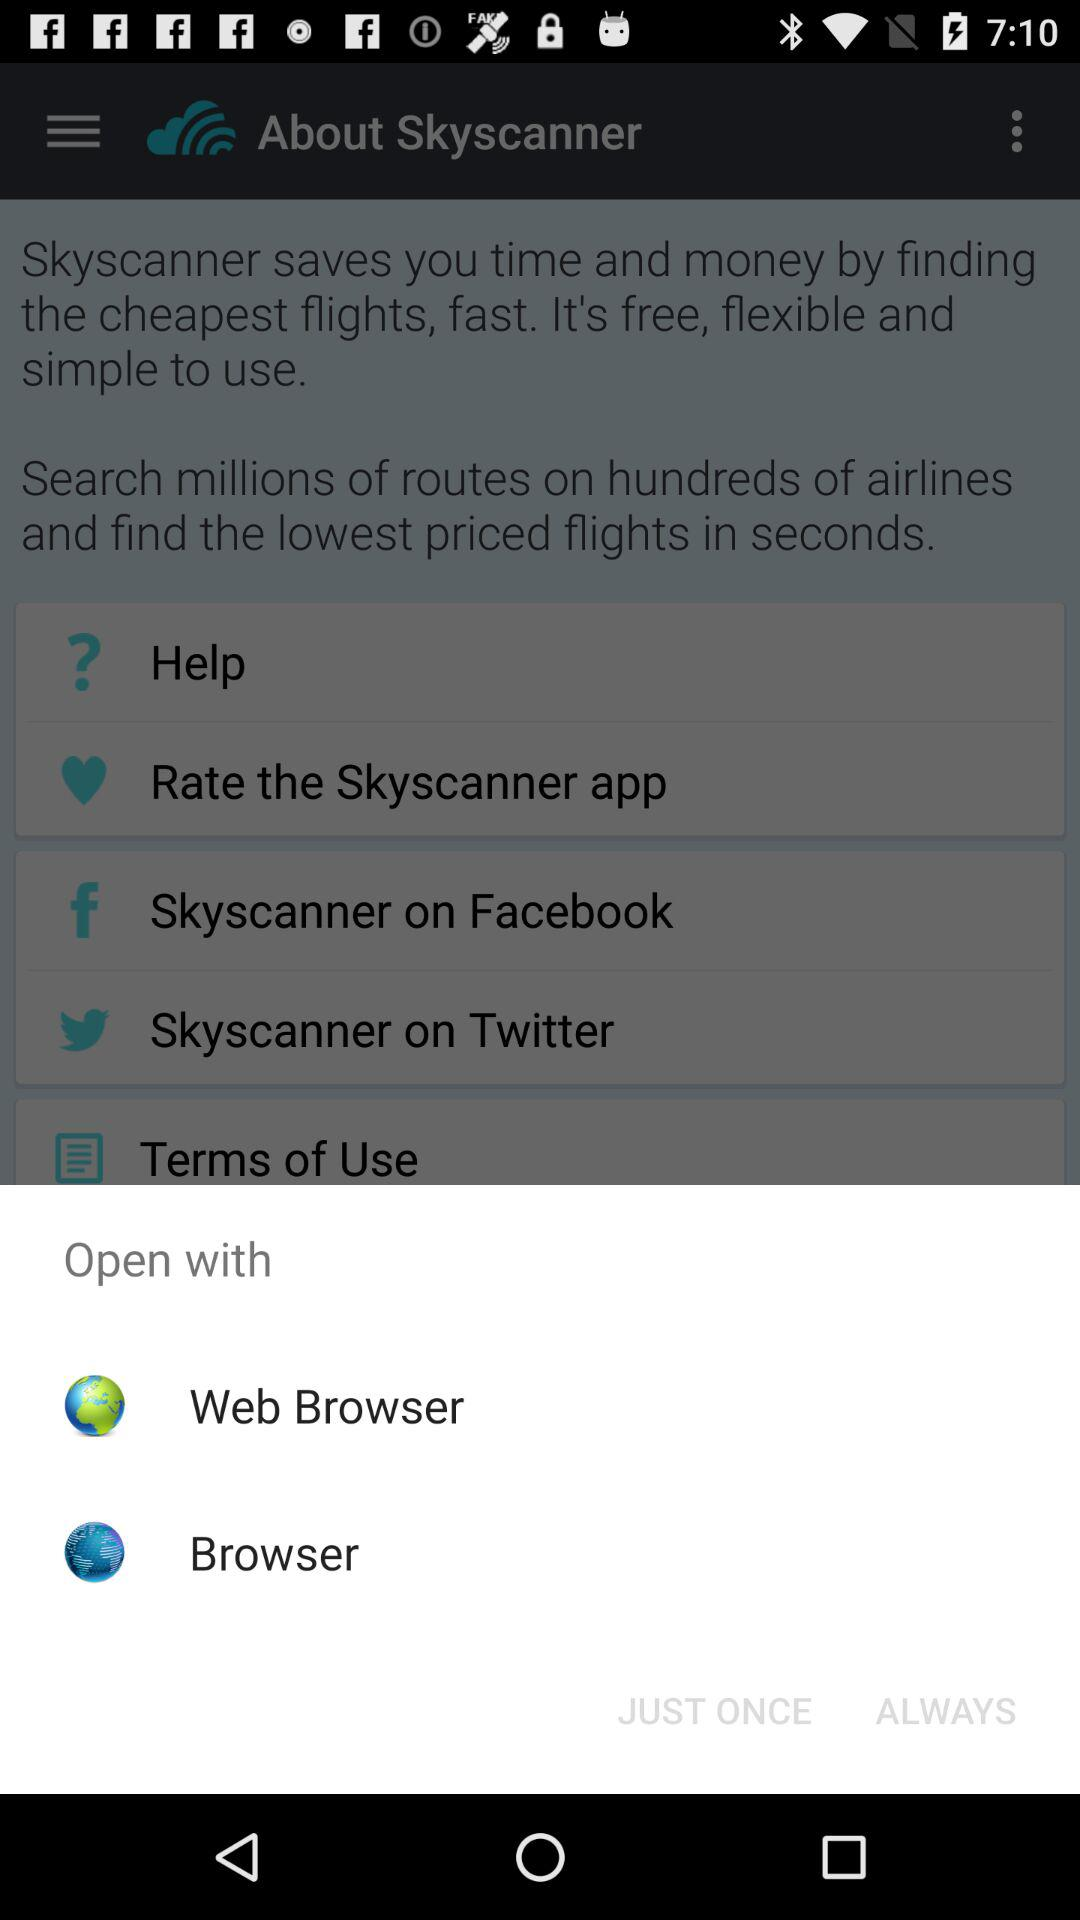Which are the different options to open? The different options are "Web Browser" and "Browser". 